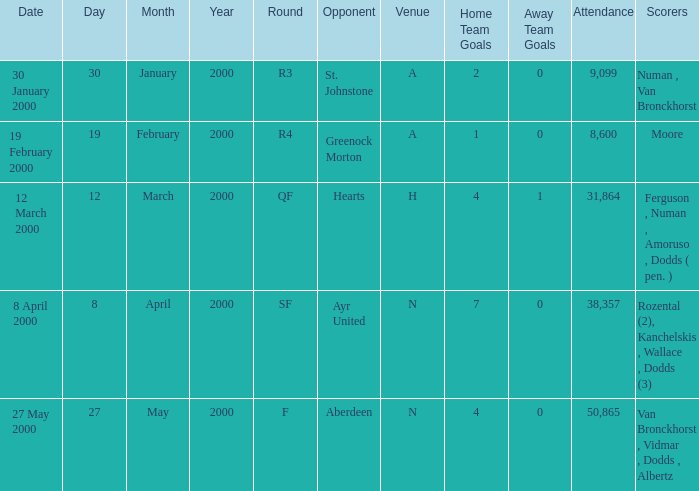Which place hosted an event on the 27th of may, 2000? N. 